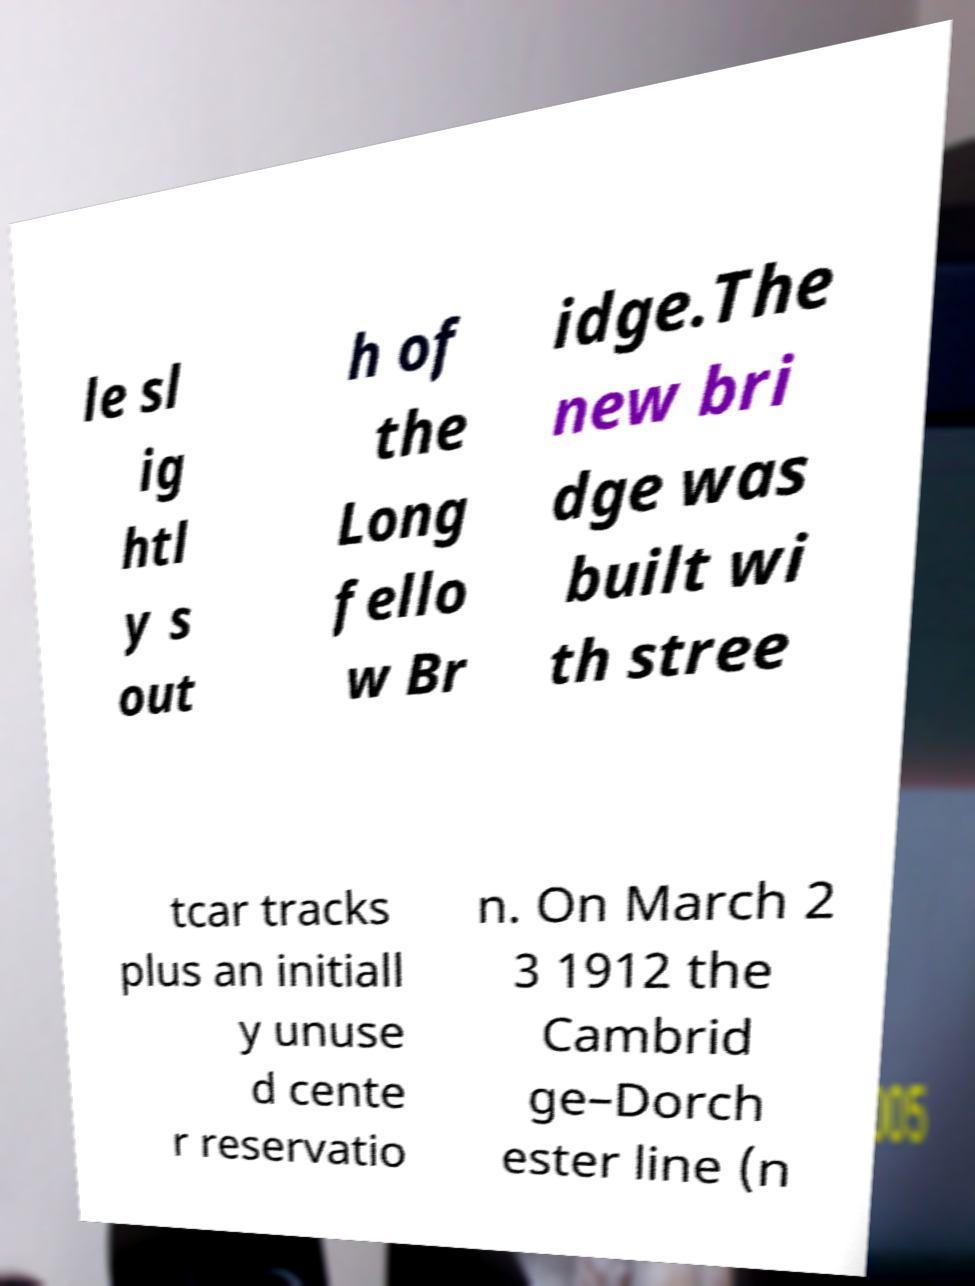I need the written content from this picture converted into text. Can you do that? le sl ig htl y s out h of the Long fello w Br idge.The new bri dge was built wi th stree tcar tracks plus an initiall y unuse d cente r reservatio n. On March 2 3 1912 the Cambrid ge–Dorch ester line (n 